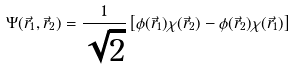Convert formula to latex. <formula><loc_0><loc_0><loc_500><loc_500>\Psi ( \vec { r } _ { 1 } , \vec { r } _ { 2 } ) = \frac { 1 } { \sqrt { 2 } } \left [ \phi ( \vec { r } _ { 1 } ) \chi ( \vec { r } _ { 2 } ) - \phi ( \vec { r } _ { 2 } ) \chi ( \vec { r } _ { 1 } ) \right ]</formula> 